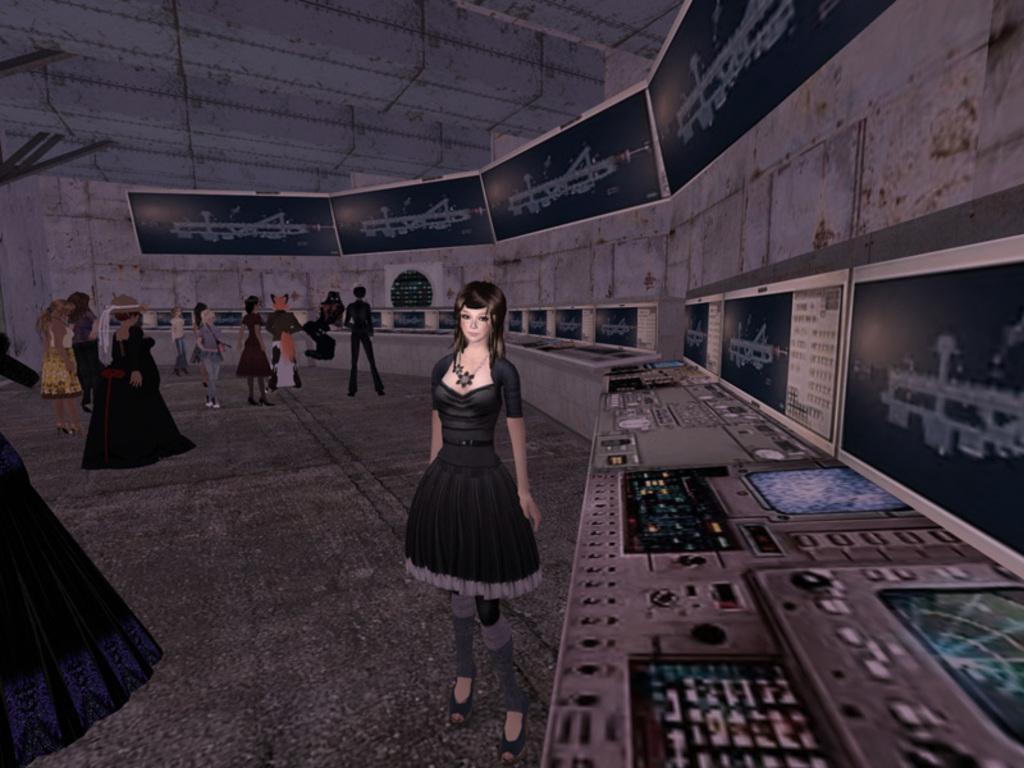Please provide a concise description of this image. This image is an edited and animated image in which there are persons and on the right side there are screens. 